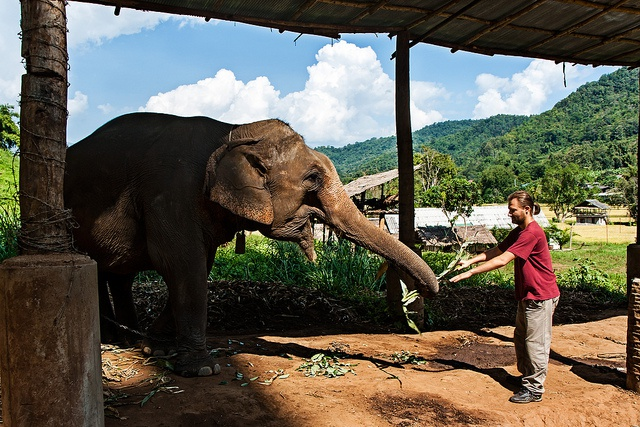Describe the objects in this image and their specific colors. I can see elephant in lightgray, black, maroon, and gray tones and people in lightgray, black, tan, maroon, and salmon tones in this image. 